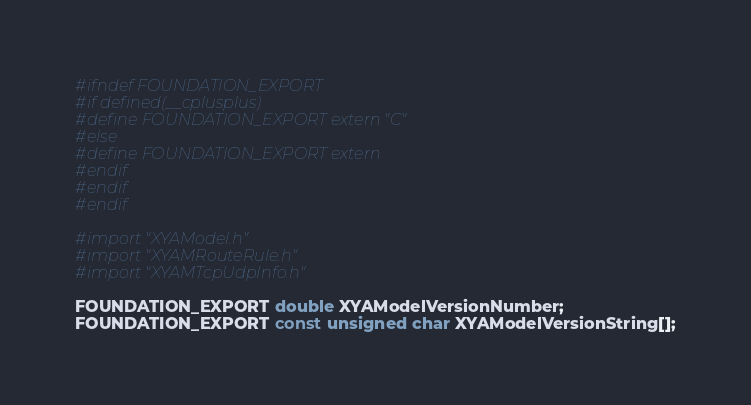<code> <loc_0><loc_0><loc_500><loc_500><_C_>#ifndef FOUNDATION_EXPORT
#if defined(__cplusplus)
#define FOUNDATION_EXPORT extern "C"
#else
#define FOUNDATION_EXPORT extern
#endif
#endif
#endif

#import "XYAModel.h"
#import "XYAMRouteRule.h"
#import "XYAMTcpUdpInfo.h"

FOUNDATION_EXPORT double XYAModelVersionNumber;
FOUNDATION_EXPORT const unsigned char XYAModelVersionString[];

</code> 